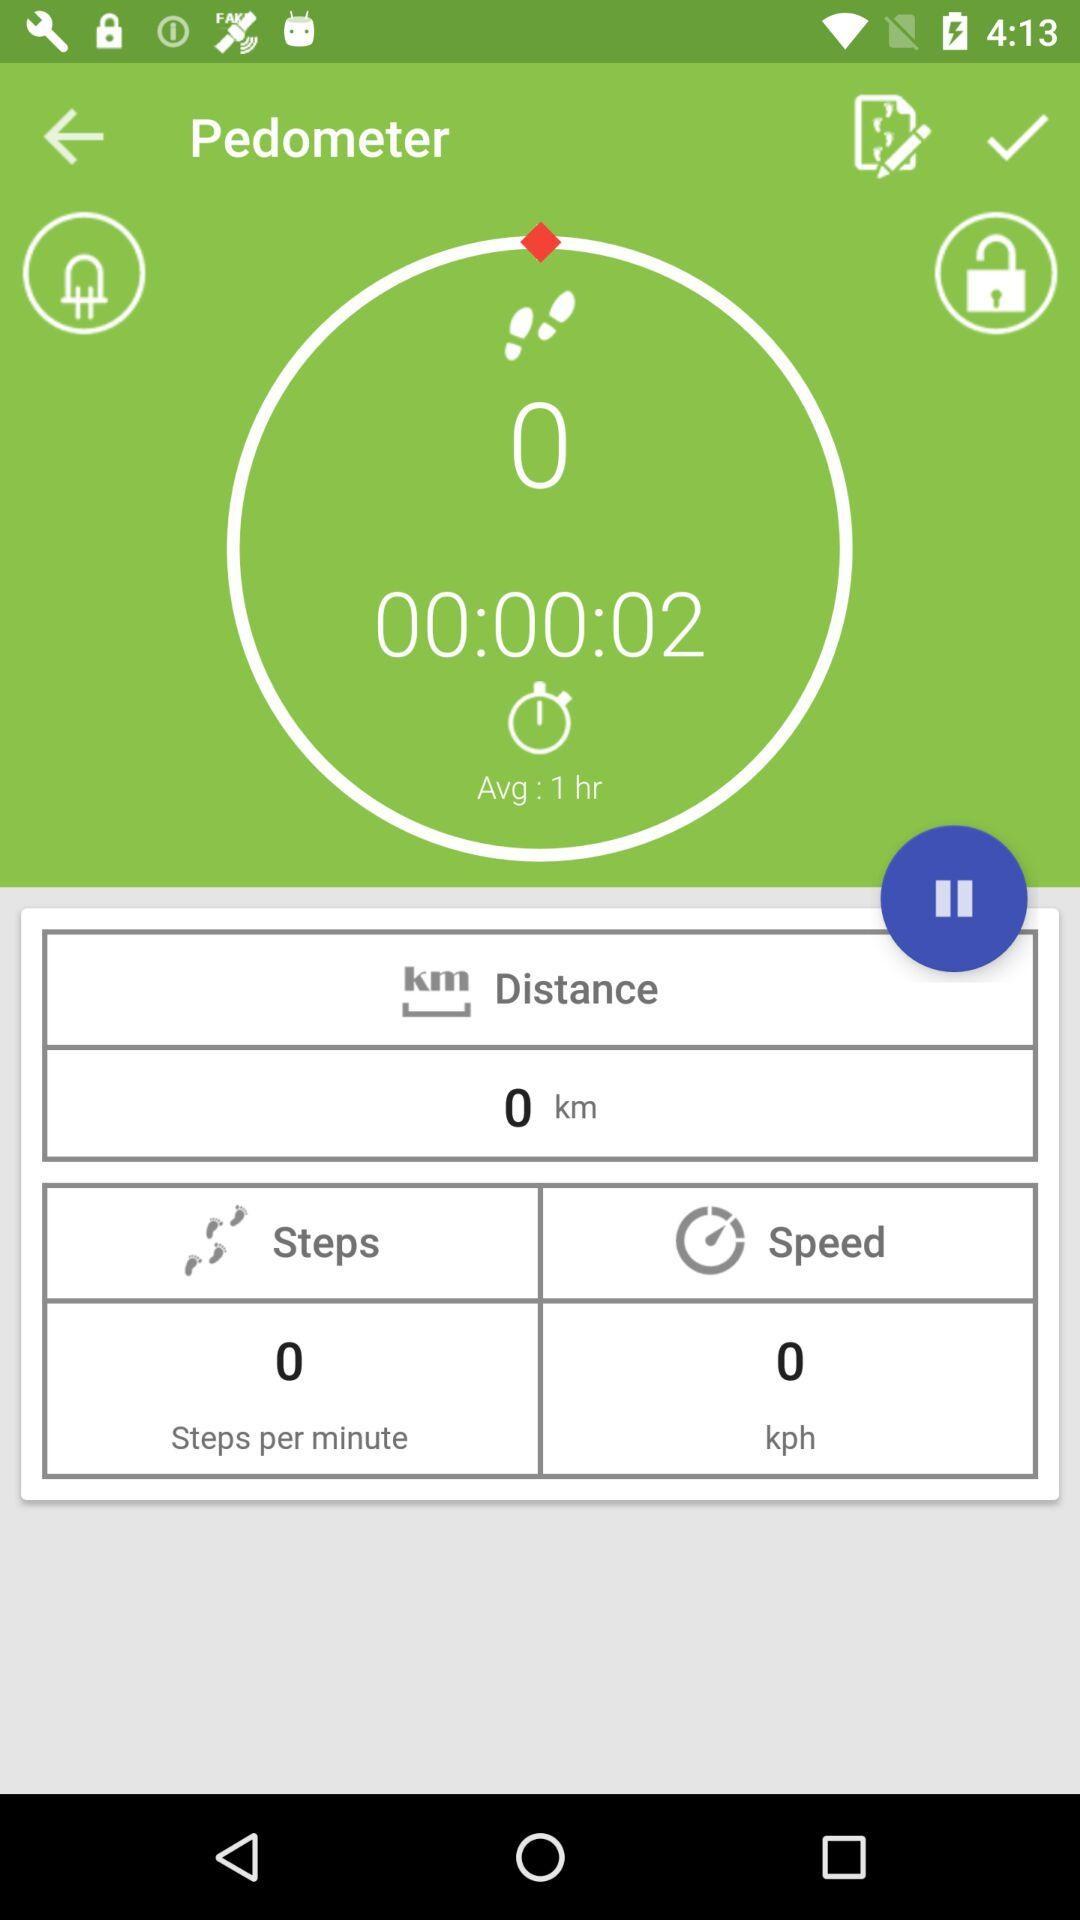What is the average duration? The average duration is 1 hour. 